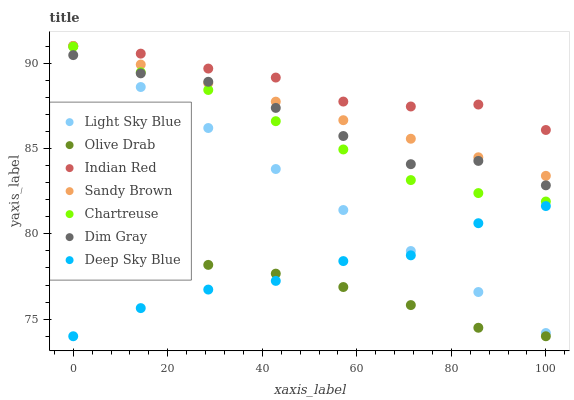Does Olive Drab have the minimum area under the curve?
Answer yes or no. Yes. Does Indian Red have the maximum area under the curve?
Answer yes or no. Yes. Does Deep Sky Blue have the minimum area under the curve?
Answer yes or no. No. Does Deep Sky Blue have the maximum area under the curve?
Answer yes or no. No. Is Sandy Brown the smoothest?
Answer yes or no. Yes. Is Dim Gray the roughest?
Answer yes or no. Yes. Is Deep Sky Blue the smoothest?
Answer yes or no. No. Is Deep Sky Blue the roughest?
Answer yes or no. No. Does Deep Sky Blue have the lowest value?
Answer yes or no. Yes. Does Chartreuse have the lowest value?
Answer yes or no. No. Does Sandy Brown have the highest value?
Answer yes or no. Yes. Does Deep Sky Blue have the highest value?
Answer yes or no. No. Is Deep Sky Blue less than Indian Red?
Answer yes or no. Yes. Is Sandy Brown greater than Deep Sky Blue?
Answer yes or no. Yes. Does Indian Red intersect Light Sky Blue?
Answer yes or no. Yes. Is Indian Red less than Light Sky Blue?
Answer yes or no. No. Is Indian Red greater than Light Sky Blue?
Answer yes or no. No. Does Deep Sky Blue intersect Indian Red?
Answer yes or no. No. 